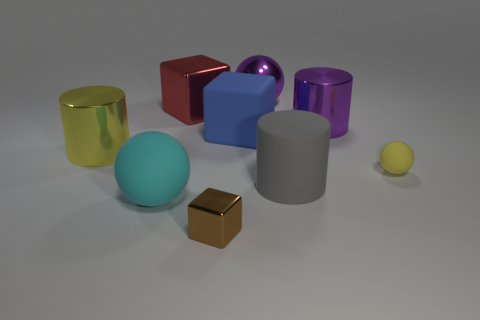Subtract 1 cubes. How many cubes are left? 2 Subtract all big blocks. How many blocks are left? 1 Add 1 yellow spheres. How many objects exist? 10 Subtract all cylinders. How many objects are left? 6 Add 1 big blue shiny cylinders. How many big blue shiny cylinders exist? 1 Subtract 0 yellow blocks. How many objects are left? 9 Subtract all tiny yellow rubber things. Subtract all tiny brown metal blocks. How many objects are left? 7 Add 4 large cyan rubber balls. How many large cyan rubber balls are left? 5 